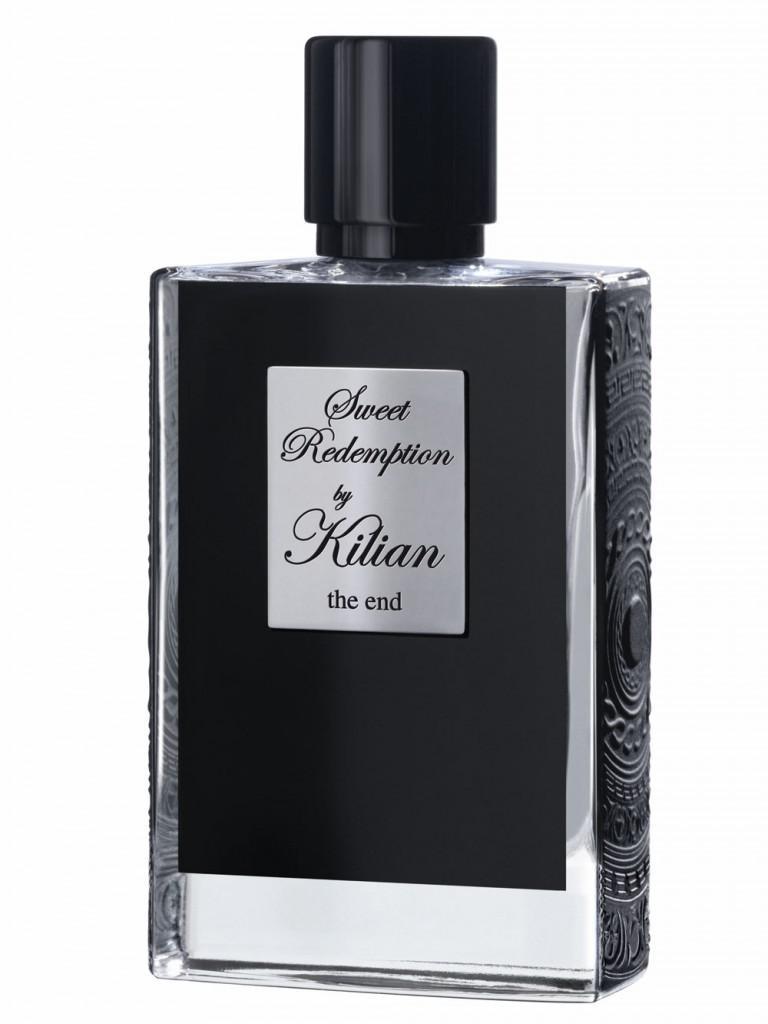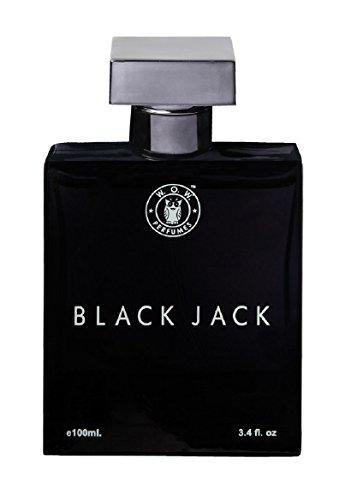The first image is the image on the left, the second image is the image on the right. Evaluate the accuracy of this statement regarding the images: "One image features a black rectangular container with a flat black lid nearly as wide as the bottle.". Is it true? Answer yes or no. No. The first image is the image on the left, the second image is the image on the right. For the images shown, is this caption "One square shaped bottle of men's cologne is shown in each of two images, one with a round cap and the other with a square cap." true? Answer yes or no. Yes. 